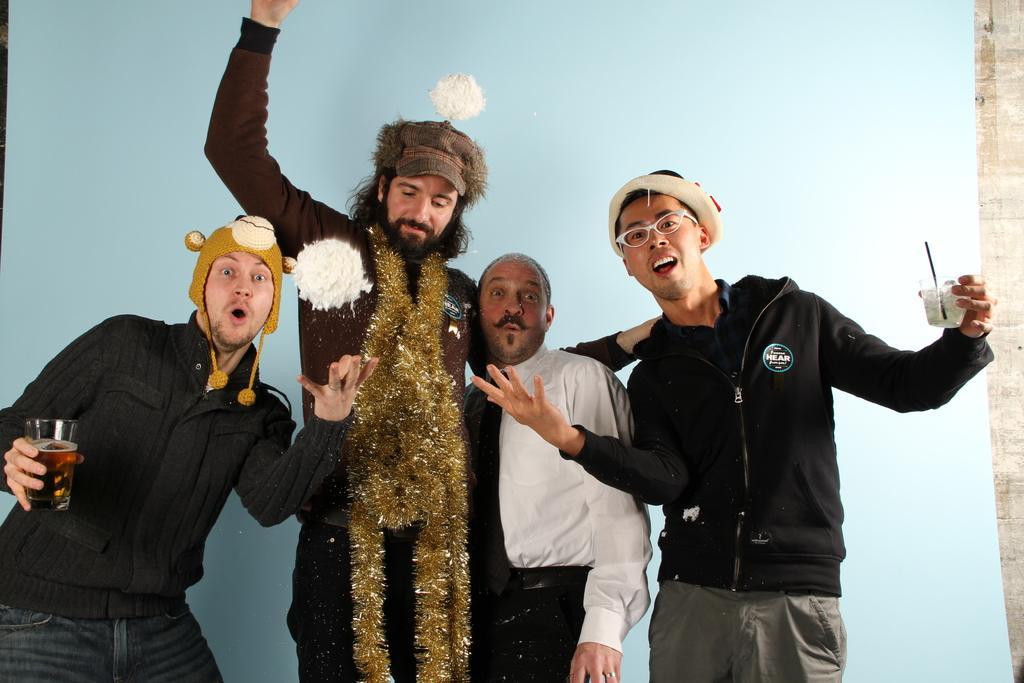How would you summarize this image in a sentence or two? In the front of the image there are four people. Among them two people are holding objects and one person wore golden tinsel garland and cap. In the background of the image there is a banner.   